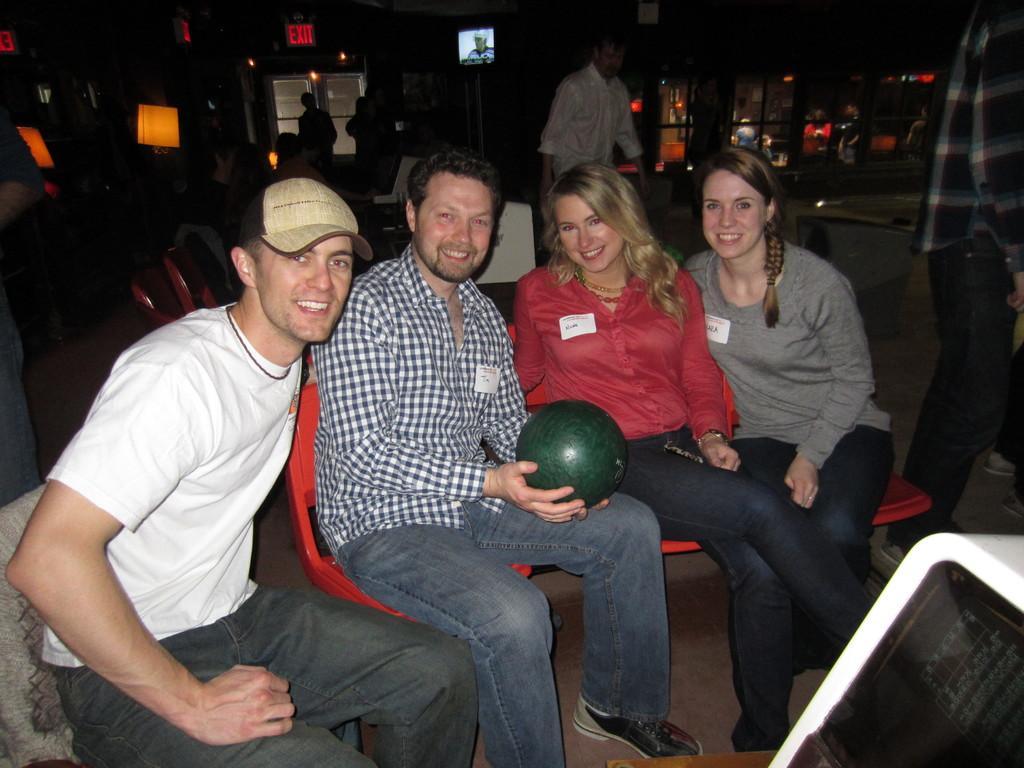Could you give a brief overview of what you see in this image? In this image we can see a group of people sitting on the chairs. In that a man is holding a ball. On the backside we can see a window, a signboard, a television screen and some people standing. 